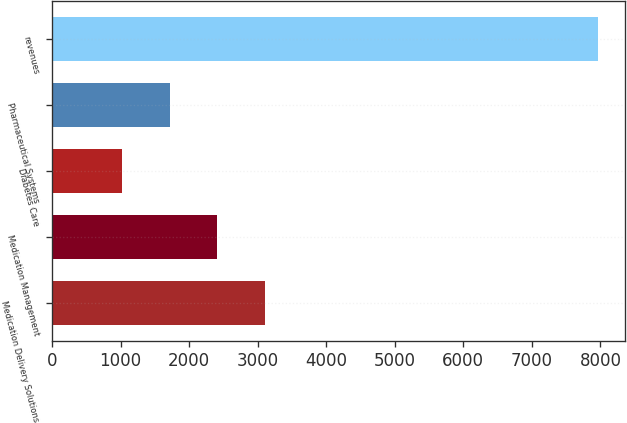Convert chart. <chart><loc_0><loc_0><loc_500><loc_500><bar_chart><fcel>Medication Delivery Solutions<fcel>Medication Management<fcel>Diabetes Care<fcel>Pharmaceutical Systems<fcel>revenues<nl><fcel>3105.6<fcel>2411.4<fcel>1023<fcel>1717.2<fcel>7965<nl></chart> 